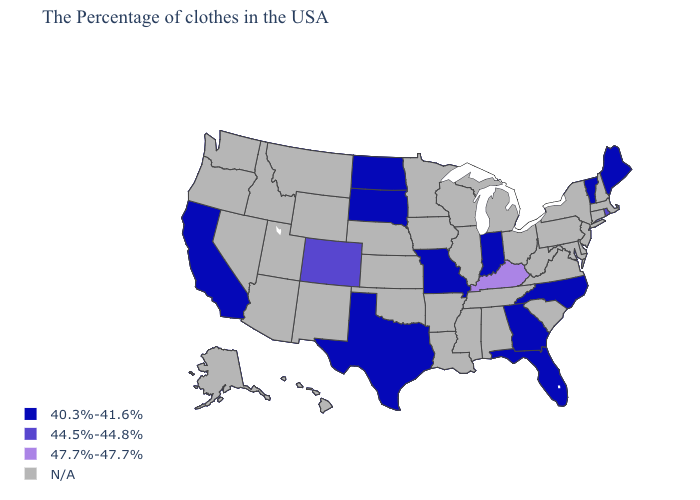Does the first symbol in the legend represent the smallest category?
Write a very short answer. Yes. Name the states that have a value in the range N/A?
Quick response, please. Massachusetts, New Hampshire, Connecticut, New York, New Jersey, Delaware, Maryland, Pennsylvania, Virginia, South Carolina, West Virginia, Ohio, Michigan, Alabama, Tennessee, Wisconsin, Illinois, Mississippi, Louisiana, Arkansas, Minnesota, Iowa, Kansas, Nebraska, Oklahoma, Wyoming, New Mexico, Utah, Montana, Arizona, Idaho, Nevada, Washington, Oregon, Alaska, Hawaii. What is the value of Louisiana?
Quick response, please. N/A. What is the value of Iowa?
Give a very brief answer. N/A. What is the value of New Jersey?
Answer briefly. N/A. What is the value of Hawaii?
Short answer required. N/A. Name the states that have a value in the range 44.5%-44.8%?
Answer briefly. Rhode Island, Colorado. What is the value of North Carolina?
Concise answer only. 40.3%-41.6%. Name the states that have a value in the range 47.7%-47.7%?
Short answer required. Kentucky. Which states have the highest value in the USA?
Answer briefly. Kentucky. What is the value of Delaware?
Quick response, please. N/A. 